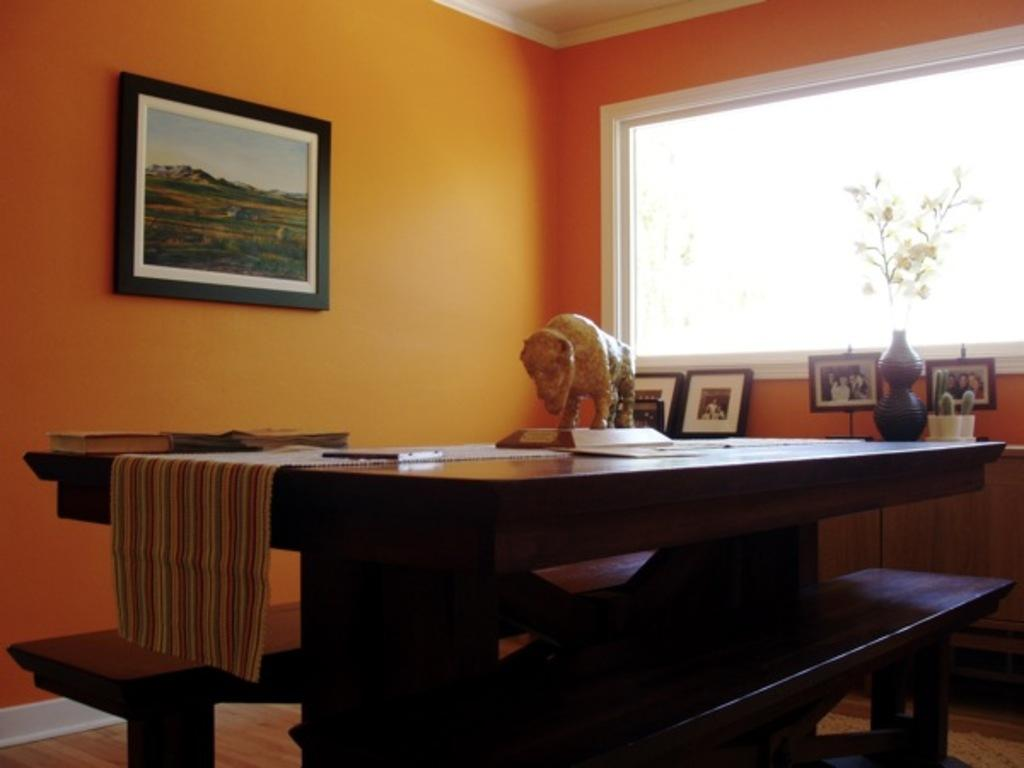What objects can be seen in the image? There are books and a mat in the image. What can be found on a table in the image? There is a decoration on a table in the image. What is visible in the background of the image? There are frames, a houseplant, a window, and a wall in the background of the image. What type of agreement is being discussed by the goose and the cracker in the image? There is no goose or cracker present in the image, and therefore no such discussion can be observed. 